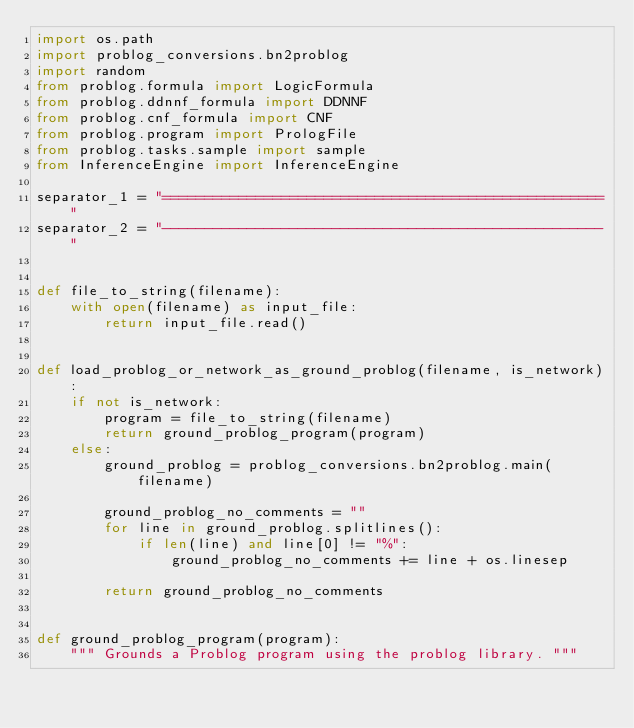Convert code to text. <code><loc_0><loc_0><loc_500><loc_500><_Python_>import os.path
import problog_conversions.bn2problog
import random
from problog.formula import LogicFormula
from problog.ddnnf_formula import DDNNF
from problog.cnf_formula import CNF
from problog.program import PrologFile
from problog.tasks.sample import sample
from InferenceEngine import InferenceEngine

separator_1 = "===================================================="
separator_2 = "----------------------------------------------------"


def file_to_string(filename):
    with open(filename) as input_file:
        return input_file.read()


def load_problog_or_network_as_ground_problog(filename, is_network):
    if not is_network:
        program = file_to_string(filename)
        return ground_problog_program(program)
    else:
        ground_problog = problog_conversions.bn2problog.main(filename)

        ground_problog_no_comments = ""
        for line in ground_problog.splitlines():
            if len(line) and line[0] != "%":
                ground_problog_no_comments += line + os.linesep

        return ground_problog_no_comments


def ground_problog_program(program):
    """ Grounds a Problog program using the problog library. """</code> 